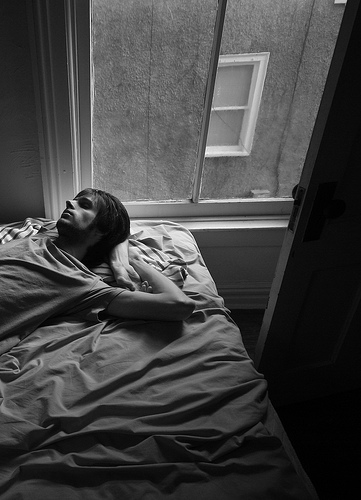What is the person that is lying lying on? The person lying is on a bed. 